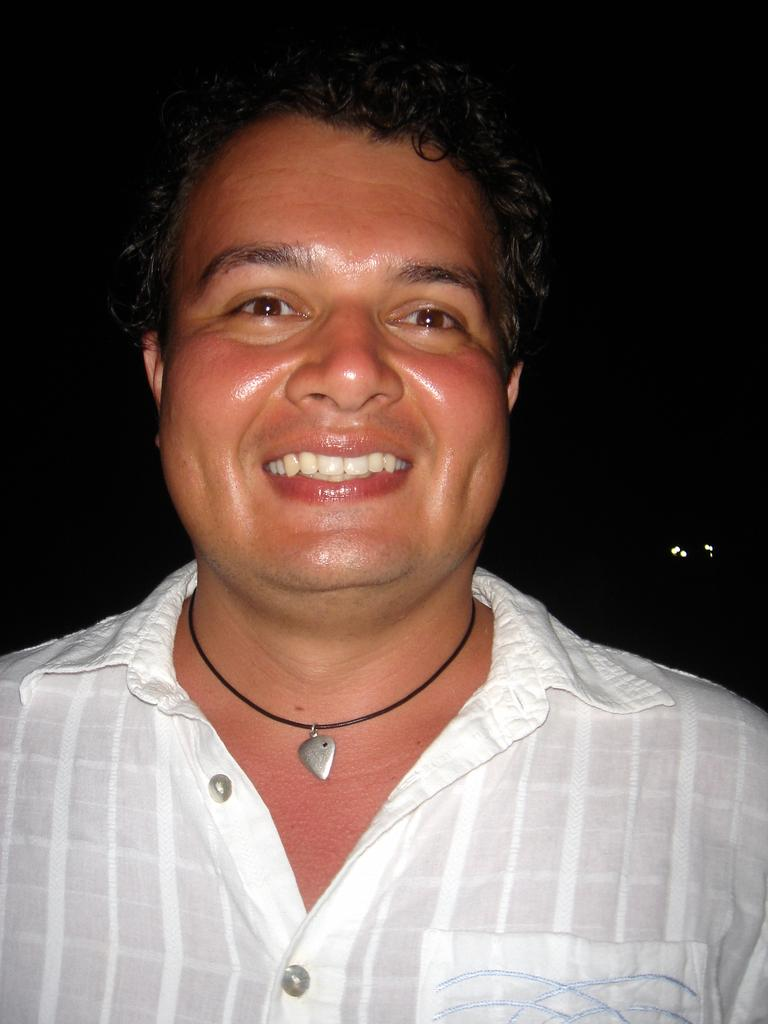Who is present in the image? There is a man in the image. What is the man's facial expression? The man is smiling. What object can be seen in the image? There is a locket in the image. What can be observed about the background of the image? The background of the image is dark. What is the current condition of the office in the image? There is no office present in the image; it features a man with a locket and a dark background. 